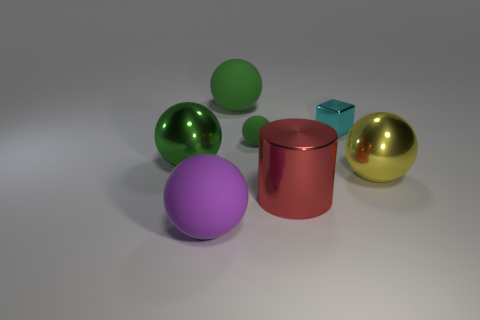How many green spheres must be subtracted to get 1 green spheres? 2 Add 1 small yellow metal cylinders. How many objects exist? 8 Subtract all purple balls. How many balls are left? 4 Subtract all large purple spheres. How many spheres are left? 4 Subtract all cylinders. How many objects are left? 6 Subtract 3 balls. How many balls are left? 2 Subtract all small purple shiny cylinders. Subtract all small cyan cubes. How many objects are left? 6 Add 3 red shiny cylinders. How many red shiny cylinders are left? 4 Add 2 spheres. How many spheres exist? 7 Subtract 1 red cylinders. How many objects are left? 6 